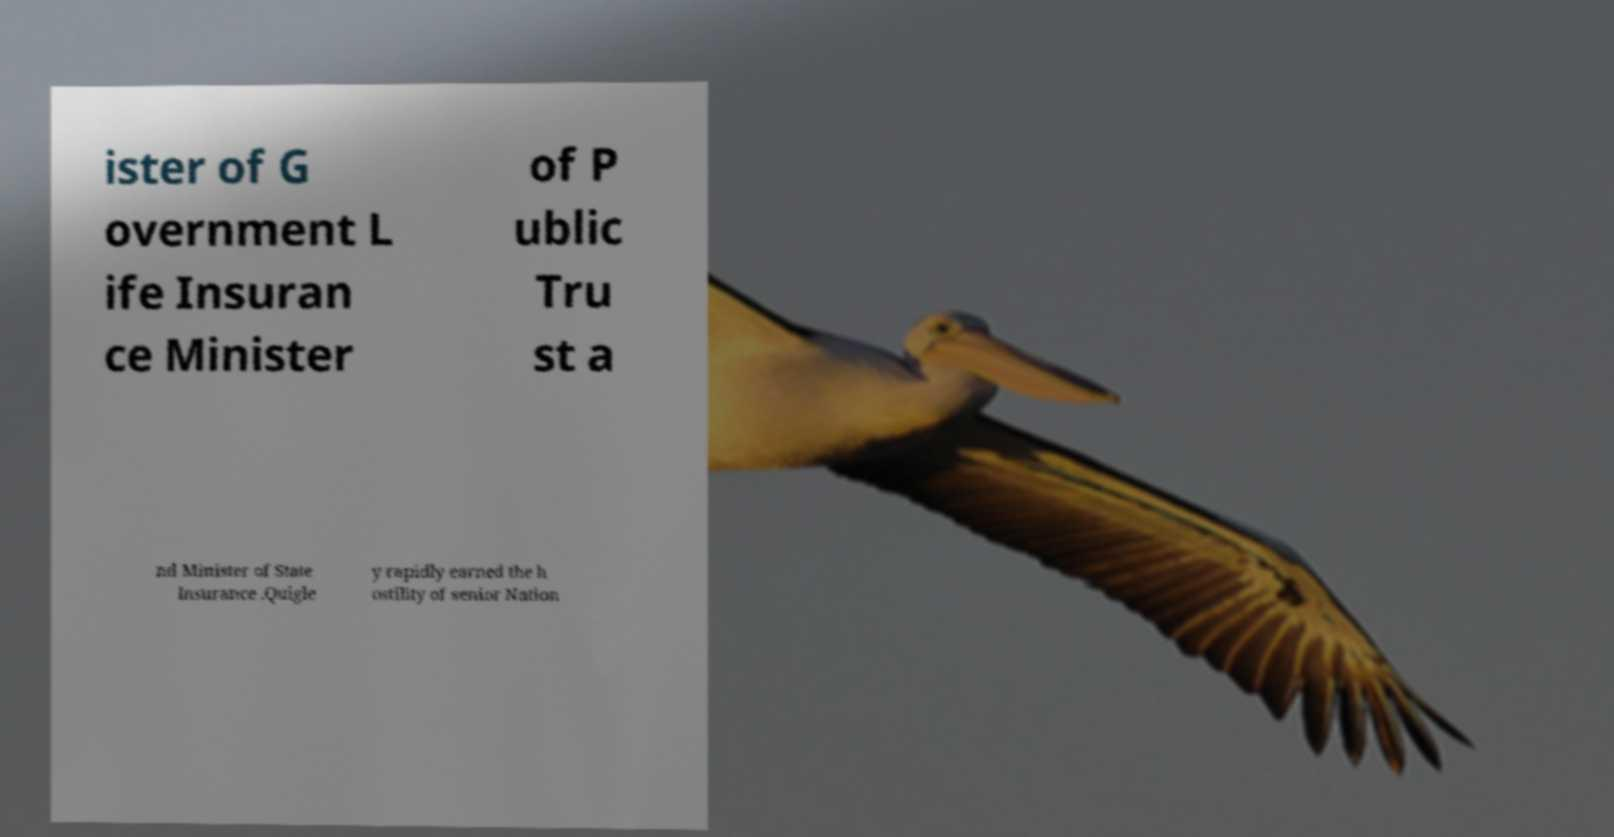Could you assist in decoding the text presented in this image and type it out clearly? ister of G overnment L ife Insuran ce Minister of P ublic Tru st a nd Minister of State Insurance .Quigle y rapidly earned the h ostility of senior Nation 